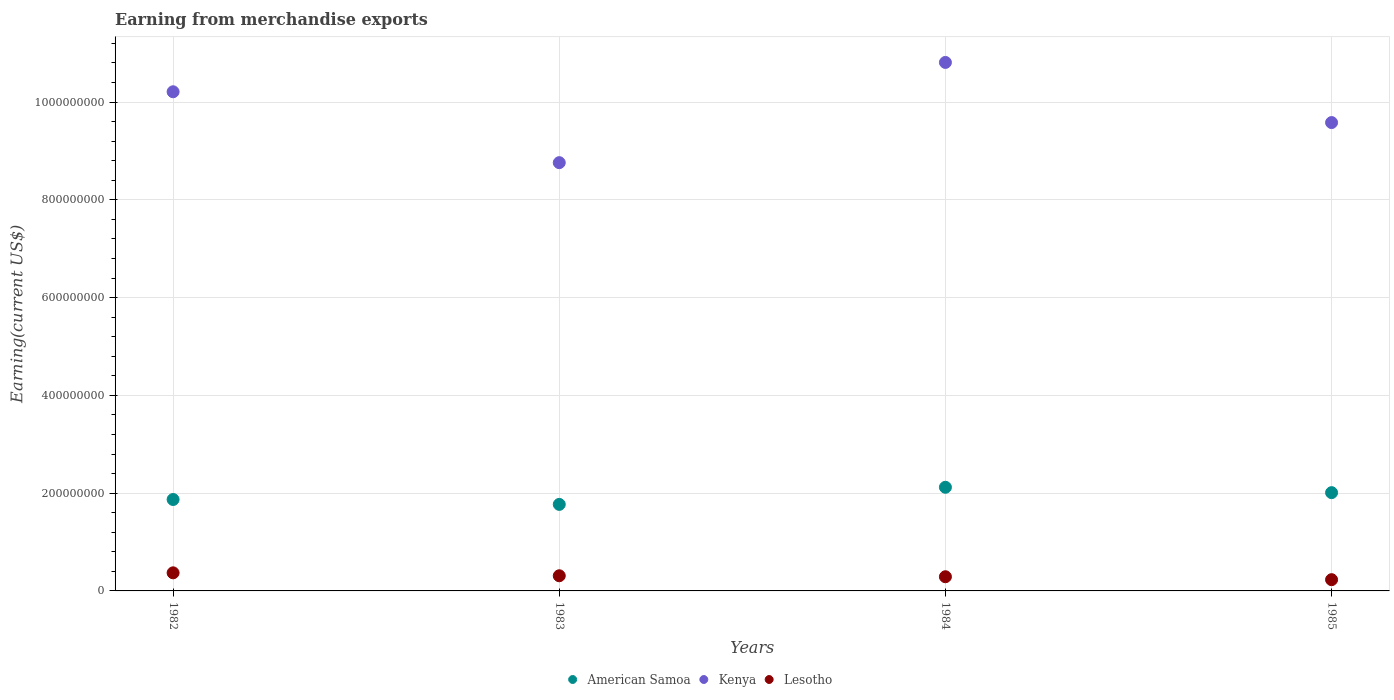How many different coloured dotlines are there?
Provide a short and direct response. 3. Is the number of dotlines equal to the number of legend labels?
Provide a short and direct response. Yes. What is the amount earned from merchandise exports in American Samoa in 1983?
Your answer should be compact. 1.77e+08. Across all years, what is the maximum amount earned from merchandise exports in American Samoa?
Offer a terse response. 2.12e+08. Across all years, what is the minimum amount earned from merchandise exports in Kenya?
Ensure brevity in your answer.  8.76e+08. In which year was the amount earned from merchandise exports in Lesotho maximum?
Provide a short and direct response. 1982. In which year was the amount earned from merchandise exports in Kenya minimum?
Offer a terse response. 1983. What is the total amount earned from merchandise exports in Lesotho in the graph?
Your answer should be very brief. 1.20e+08. What is the difference between the amount earned from merchandise exports in American Samoa in 1983 and that in 1984?
Offer a very short reply. -3.50e+07. What is the difference between the amount earned from merchandise exports in Lesotho in 1984 and the amount earned from merchandise exports in American Samoa in 1982?
Your response must be concise. -1.58e+08. What is the average amount earned from merchandise exports in Lesotho per year?
Ensure brevity in your answer.  3.00e+07. In the year 1982, what is the difference between the amount earned from merchandise exports in Kenya and amount earned from merchandise exports in Lesotho?
Offer a very short reply. 9.84e+08. In how many years, is the amount earned from merchandise exports in American Samoa greater than 960000000 US$?
Provide a succinct answer. 0. What is the ratio of the amount earned from merchandise exports in Kenya in 1982 to that in 1984?
Your answer should be very brief. 0.94. Is the difference between the amount earned from merchandise exports in Kenya in 1982 and 1983 greater than the difference between the amount earned from merchandise exports in Lesotho in 1982 and 1983?
Offer a terse response. Yes. What is the difference between the highest and the second highest amount earned from merchandise exports in Kenya?
Give a very brief answer. 6.00e+07. What is the difference between the highest and the lowest amount earned from merchandise exports in American Samoa?
Give a very brief answer. 3.50e+07. In how many years, is the amount earned from merchandise exports in American Samoa greater than the average amount earned from merchandise exports in American Samoa taken over all years?
Make the answer very short. 2. Is it the case that in every year, the sum of the amount earned from merchandise exports in American Samoa and amount earned from merchandise exports in Kenya  is greater than the amount earned from merchandise exports in Lesotho?
Offer a very short reply. Yes. Does the amount earned from merchandise exports in Kenya monotonically increase over the years?
Provide a succinct answer. No. Is the amount earned from merchandise exports in Lesotho strictly greater than the amount earned from merchandise exports in Kenya over the years?
Provide a succinct answer. No. Is the amount earned from merchandise exports in Lesotho strictly less than the amount earned from merchandise exports in American Samoa over the years?
Keep it short and to the point. Yes. How many years are there in the graph?
Keep it short and to the point. 4. What is the difference between two consecutive major ticks on the Y-axis?
Provide a short and direct response. 2.00e+08. How many legend labels are there?
Your answer should be very brief. 3. What is the title of the graph?
Keep it short and to the point. Earning from merchandise exports. Does "Tanzania" appear as one of the legend labels in the graph?
Offer a very short reply. No. What is the label or title of the X-axis?
Give a very brief answer. Years. What is the label or title of the Y-axis?
Provide a succinct answer. Earning(current US$). What is the Earning(current US$) in American Samoa in 1982?
Provide a short and direct response. 1.87e+08. What is the Earning(current US$) in Kenya in 1982?
Make the answer very short. 1.02e+09. What is the Earning(current US$) of Lesotho in 1982?
Give a very brief answer. 3.70e+07. What is the Earning(current US$) of American Samoa in 1983?
Your answer should be compact. 1.77e+08. What is the Earning(current US$) in Kenya in 1983?
Provide a short and direct response. 8.76e+08. What is the Earning(current US$) of Lesotho in 1983?
Your response must be concise. 3.10e+07. What is the Earning(current US$) in American Samoa in 1984?
Provide a succinct answer. 2.12e+08. What is the Earning(current US$) in Kenya in 1984?
Keep it short and to the point. 1.08e+09. What is the Earning(current US$) in Lesotho in 1984?
Ensure brevity in your answer.  2.90e+07. What is the Earning(current US$) of American Samoa in 1985?
Your answer should be very brief. 2.01e+08. What is the Earning(current US$) of Kenya in 1985?
Your answer should be compact. 9.58e+08. What is the Earning(current US$) of Lesotho in 1985?
Ensure brevity in your answer.  2.30e+07. Across all years, what is the maximum Earning(current US$) of American Samoa?
Offer a very short reply. 2.12e+08. Across all years, what is the maximum Earning(current US$) in Kenya?
Offer a terse response. 1.08e+09. Across all years, what is the maximum Earning(current US$) of Lesotho?
Offer a terse response. 3.70e+07. Across all years, what is the minimum Earning(current US$) of American Samoa?
Your answer should be compact. 1.77e+08. Across all years, what is the minimum Earning(current US$) of Kenya?
Your answer should be compact. 8.76e+08. Across all years, what is the minimum Earning(current US$) of Lesotho?
Your response must be concise. 2.30e+07. What is the total Earning(current US$) in American Samoa in the graph?
Provide a short and direct response. 7.77e+08. What is the total Earning(current US$) of Kenya in the graph?
Your answer should be compact. 3.94e+09. What is the total Earning(current US$) in Lesotho in the graph?
Provide a succinct answer. 1.20e+08. What is the difference between the Earning(current US$) in Kenya in 1982 and that in 1983?
Ensure brevity in your answer.  1.45e+08. What is the difference between the Earning(current US$) in American Samoa in 1982 and that in 1984?
Keep it short and to the point. -2.50e+07. What is the difference between the Earning(current US$) in Kenya in 1982 and that in 1984?
Your response must be concise. -6.00e+07. What is the difference between the Earning(current US$) in American Samoa in 1982 and that in 1985?
Give a very brief answer. -1.40e+07. What is the difference between the Earning(current US$) in Kenya in 1982 and that in 1985?
Give a very brief answer. 6.30e+07. What is the difference between the Earning(current US$) in Lesotho in 1982 and that in 1985?
Offer a very short reply. 1.40e+07. What is the difference between the Earning(current US$) of American Samoa in 1983 and that in 1984?
Provide a succinct answer. -3.50e+07. What is the difference between the Earning(current US$) of Kenya in 1983 and that in 1984?
Your response must be concise. -2.05e+08. What is the difference between the Earning(current US$) of American Samoa in 1983 and that in 1985?
Keep it short and to the point. -2.40e+07. What is the difference between the Earning(current US$) of Kenya in 1983 and that in 1985?
Your response must be concise. -8.20e+07. What is the difference between the Earning(current US$) of American Samoa in 1984 and that in 1985?
Offer a very short reply. 1.10e+07. What is the difference between the Earning(current US$) in Kenya in 1984 and that in 1985?
Offer a very short reply. 1.23e+08. What is the difference between the Earning(current US$) in Lesotho in 1984 and that in 1985?
Your response must be concise. 6.00e+06. What is the difference between the Earning(current US$) of American Samoa in 1982 and the Earning(current US$) of Kenya in 1983?
Your response must be concise. -6.89e+08. What is the difference between the Earning(current US$) in American Samoa in 1982 and the Earning(current US$) in Lesotho in 1983?
Ensure brevity in your answer.  1.56e+08. What is the difference between the Earning(current US$) of Kenya in 1982 and the Earning(current US$) of Lesotho in 1983?
Your answer should be compact. 9.90e+08. What is the difference between the Earning(current US$) of American Samoa in 1982 and the Earning(current US$) of Kenya in 1984?
Provide a short and direct response. -8.94e+08. What is the difference between the Earning(current US$) of American Samoa in 1982 and the Earning(current US$) of Lesotho in 1984?
Offer a terse response. 1.58e+08. What is the difference between the Earning(current US$) of Kenya in 1982 and the Earning(current US$) of Lesotho in 1984?
Your answer should be very brief. 9.92e+08. What is the difference between the Earning(current US$) of American Samoa in 1982 and the Earning(current US$) of Kenya in 1985?
Ensure brevity in your answer.  -7.71e+08. What is the difference between the Earning(current US$) in American Samoa in 1982 and the Earning(current US$) in Lesotho in 1985?
Ensure brevity in your answer.  1.64e+08. What is the difference between the Earning(current US$) of Kenya in 1982 and the Earning(current US$) of Lesotho in 1985?
Provide a succinct answer. 9.98e+08. What is the difference between the Earning(current US$) of American Samoa in 1983 and the Earning(current US$) of Kenya in 1984?
Offer a terse response. -9.04e+08. What is the difference between the Earning(current US$) in American Samoa in 1983 and the Earning(current US$) in Lesotho in 1984?
Your answer should be compact. 1.48e+08. What is the difference between the Earning(current US$) of Kenya in 1983 and the Earning(current US$) of Lesotho in 1984?
Ensure brevity in your answer.  8.47e+08. What is the difference between the Earning(current US$) of American Samoa in 1983 and the Earning(current US$) of Kenya in 1985?
Give a very brief answer. -7.81e+08. What is the difference between the Earning(current US$) in American Samoa in 1983 and the Earning(current US$) in Lesotho in 1985?
Keep it short and to the point. 1.54e+08. What is the difference between the Earning(current US$) in Kenya in 1983 and the Earning(current US$) in Lesotho in 1985?
Ensure brevity in your answer.  8.53e+08. What is the difference between the Earning(current US$) in American Samoa in 1984 and the Earning(current US$) in Kenya in 1985?
Your answer should be compact. -7.46e+08. What is the difference between the Earning(current US$) in American Samoa in 1984 and the Earning(current US$) in Lesotho in 1985?
Provide a succinct answer. 1.89e+08. What is the difference between the Earning(current US$) in Kenya in 1984 and the Earning(current US$) in Lesotho in 1985?
Your answer should be compact. 1.06e+09. What is the average Earning(current US$) of American Samoa per year?
Give a very brief answer. 1.94e+08. What is the average Earning(current US$) of Kenya per year?
Offer a terse response. 9.84e+08. What is the average Earning(current US$) in Lesotho per year?
Provide a succinct answer. 3.00e+07. In the year 1982, what is the difference between the Earning(current US$) of American Samoa and Earning(current US$) of Kenya?
Provide a succinct answer. -8.34e+08. In the year 1982, what is the difference between the Earning(current US$) in American Samoa and Earning(current US$) in Lesotho?
Keep it short and to the point. 1.50e+08. In the year 1982, what is the difference between the Earning(current US$) in Kenya and Earning(current US$) in Lesotho?
Offer a terse response. 9.84e+08. In the year 1983, what is the difference between the Earning(current US$) of American Samoa and Earning(current US$) of Kenya?
Make the answer very short. -6.99e+08. In the year 1983, what is the difference between the Earning(current US$) in American Samoa and Earning(current US$) in Lesotho?
Offer a very short reply. 1.46e+08. In the year 1983, what is the difference between the Earning(current US$) in Kenya and Earning(current US$) in Lesotho?
Ensure brevity in your answer.  8.45e+08. In the year 1984, what is the difference between the Earning(current US$) in American Samoa and Earning(current US$) in Kenya?
Ensure brevity in your answer.  -8.69e+08. In the year 1984, what is the difference between the Earning(current US$) in American Samoa and Earning(current US$) in Lesotho?
Your response must be concise. 1.83e+08. In the year 1984, what is the difference between the Earning(current US$) of Kenya and Earning(current US$) of Lesotho?
Offer a terse response. 1.05e+09. In the year 1985, what is the difference between the Earning(current US$) in American Samoa and Earning(current US$) in Kenya?
Offer a terse response. -7.57e+08. In the year 1985, what is the difference between the Earning(current US$) in American Samoa and Earning(current US$) in Lesotho?
Ensure brevity in your answer.  1.78e+08. In the year 1985, what is the difference between the Earning(current US$) in Kenya and Earning(current US$) in Lesotho?
Your response must be concise. 9.35e+08. What is the ratio of the Earning(current US$) of American Samoa in 1982 to that in 1983?
Provide a succinct answer. 1.06. What is the ratio of the Earning(current US$) of Kenya in 1982 to that in 1983?
Your answer should be very brief. 1.17. What is the ratio of the Earning(current US$) of Lesotho in 1982 to that in 1983?
Offer a terse response. 1.19. What is the ratio of the Earning(current US$) of American Samoa in 1982 to that in 1984?
Your answer should be compact. 0.88. What is the ratio of the Earning(current US$) of Kenya in 1982 to that in 1984?
Provide a short and direct response. 0.94. What is the ratio of the Earning(current US$) in Lesotho in 1982 to that in 1984?
Keep it short and to the point. 1.28. What is the ratio of the Earning(current US$) of American Samoa in 1982 to that in 1985?
Provide a short and direct response. 0.93. What is the ratio of the Earning(current US$) in Kenya in 1982 to that in 1985?
Offer a very short reply. 1.07. What is the ratio of the Earning(current US$) in Lesotho in 1982 to that in 1985?
Offer a very short reply. 1.61. What is the ratio of the Earning(current US$) in American Samoa in 1983 to that in 1984?
Keep it short and to the point. 0.83. What is the ratio of the Earning(current US$) in Kenya in 1983 to that in 1984?
Your response must be concise. 0.81. What is the ratio of the Earning(current US$) in Lesotho in 1983 to that in 1984?
Keep it short and to the point. 1.07. What is the ratio of the Earning(current US$) of American Samoa in 1983 to that in 1985?
Make the answer very short. 0.88. What is the ratio of the Earning(current US$) in Kenya in 1983 to that in 1985?
Your answer should be compact. 0.91. What is the ratio of the Earning(current US$) in Lesotho in 1983 to that in 1985?
Offer a very short reply. 1.35. What is the ratio of the Earning(current US$) of American Samoa in 1984 to that in 1985?
Your answer should be very brief. 1.05. What is the ratio of the Earning(current US$) of Kenya in 1984 to that in 1985?
Make the answer very short. 1.13. What is the ratio of the Earning(current US$) in Lesotho in 1984 to that in 1985?
Your answer should be compact. 1.26. What is the difference between the highest and the second highest Earning(current US$) in American Samoa?
Provide a short and direct response. 1.10e+07. What is the difference between the highest and the second highest Earning(current US$) of Kenya?
Your response must be concise. 6.00e+07. What is the difference between the highest and the lowest Earning(current US$) in American Samoa?
Your response must be concise. 3.50e+07. What is the difference between the highest and the lowest Earning(current US$) in Kenya?
Ensure brevity in your answer.  2.05e+08. What is the difference between the highest and the lowest Earning(current US$) in Lesotho?
Provide a succinct answer. 1.40e+07. 